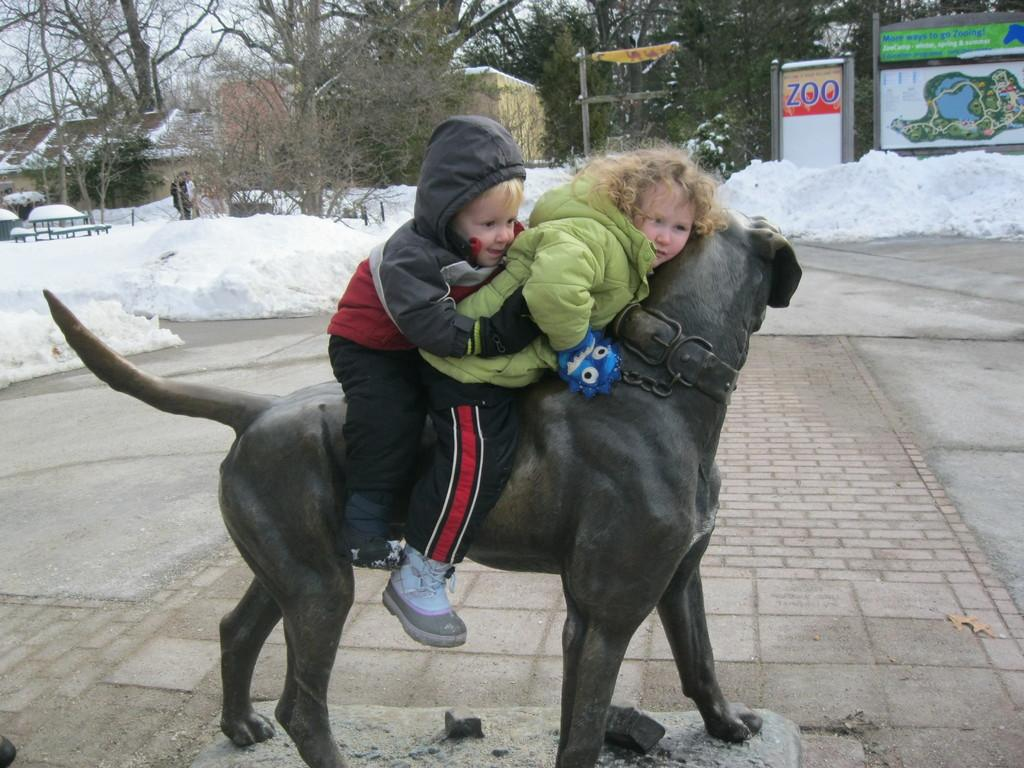How many children are in the image? There are two children in the image. What are the children doing in the image? The children are sitting on a sculpture of an animal. What can be seen in the background of the image? There is snow, two boards, and trees in the background of the image. What type of experience did the children have before the competition in the image? There is no mention of a competition or any experience in the image, so we cannot answer that question. 